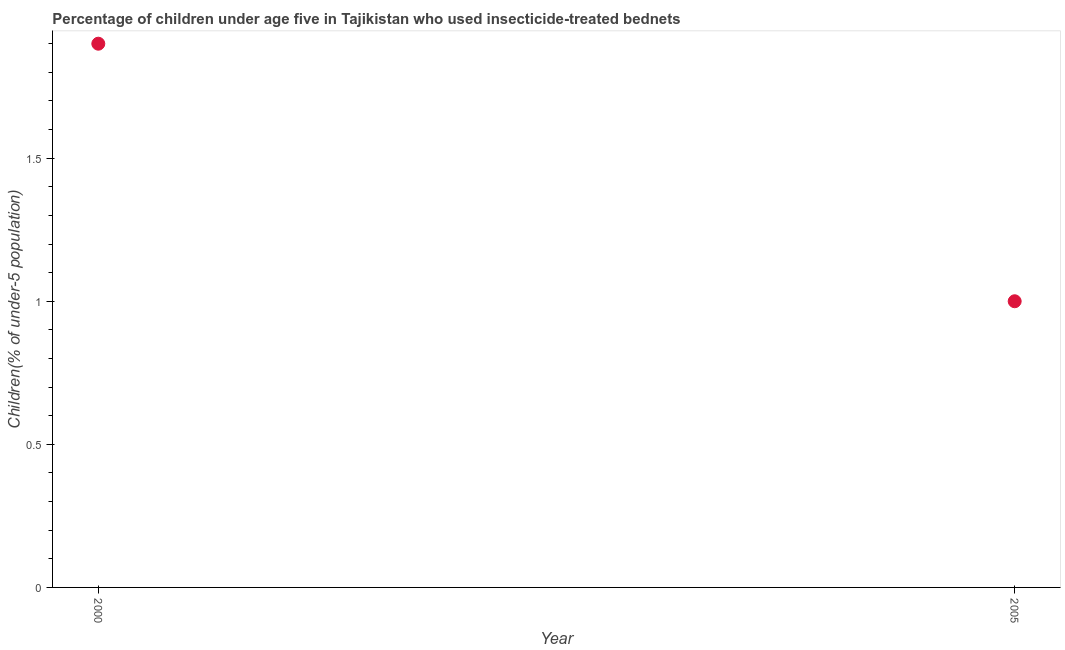What is the percentage of children who use of insecticide-treated bed nets in 2000?
Your answer should be compact. 1.9. Across all years, what is the maximum percentage of children who use of insecticide-treated bed nets?
Offer a very short reply. 1.9. What is the sum of the percentage of children who use of insecticide-treated bed nets?
Make the answer very short. 2.9. What is the difference between the percentage of children who use of insecticide-treated bed nets in 2000 and 2005?
Your answer should be compact. 0.9. What is the average percentage of children who use of insecticide-treated bed nets per year?
Your answer should be compact. 1.45. What is the median percentage of children who use of insecticide-treated bed nets?
Offer a very short reply. 1.45. What is the ratio of the percentage of children who use of insecticide-treated bed nets in 2000 to that in 2005?
Your answer should be very brief. 1.9. In how many years, is the percentage of children who use of insecticide-treated bed nets greater than the average percentage of children who use of insecticide-treated bed nets taken over all years?
Offer a very short reply. 1. How many years are there in the graph?
Ensure brevity in your answer.  2. What is the difference between two consecutive major ticks on the Y-axis?
Make the answer very short. 0.5. What is the title of the graph?
Make the answer very short. Percentage of children under age five in Tajikistan who used insecticide-treated bednets. What is the label or title of the Y-axis?
Offer a very short reply. Children(% of under-5 population). What is the Children(% of under-5 population) in 2000?
Ensure brevity in your answer.  1.9. What is the difference between the Children(% of under-5 population) in 2000 and 2005?
Provide a succinct answer. 0.9. 